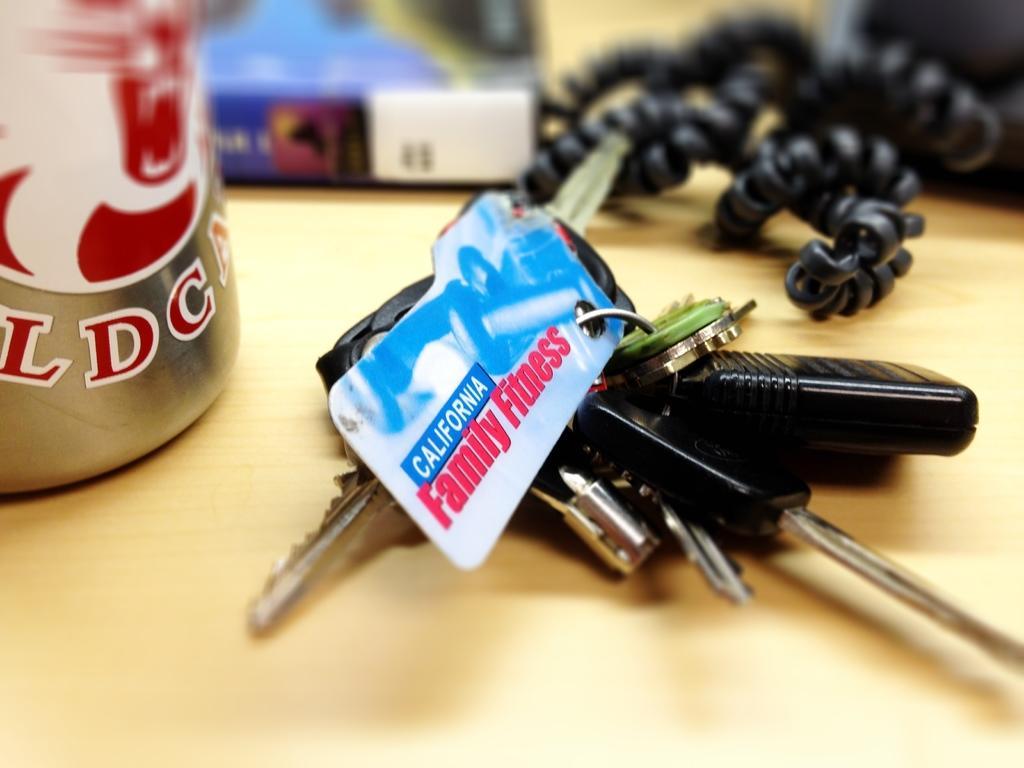Can you describe this image briefly? Background portion of the picture is blur. In this picture we can see a wooden platform and on the platform we can see keychain, keys, handset cord and an object. 